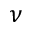Convert formula to latex. <formula><loc_0><loc_0><loc_500><loc_500>\nu</formula> 